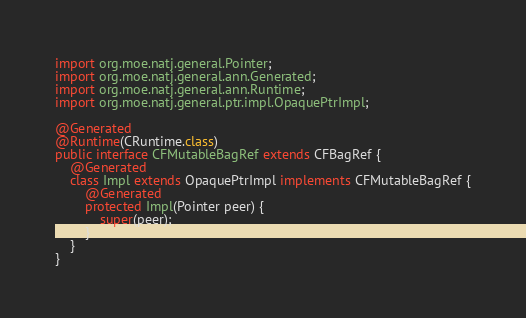Convert code to text. <code><loc_0><loc_0><loc_500><loc_500><_Java_>import org.moe.natj.general.Pointer;
import org.moe.natj.general.ann.Generated;
import org.moe.natj.general.ann.Runtime;
import org.moe.natj.general.ptr.impl.OpaquePtrImpl;

@Generated
@Runtime(CRuntime.class)
public interface CFMutableBagRef extends CFBagRef {
    @Generated
    class Impl extends OpaquePtrImpl implements CFMutableBagRef {
        @Generated
        protected Impl(Pointer peer) {
            super(peer);
        }
    }
}
</code> 